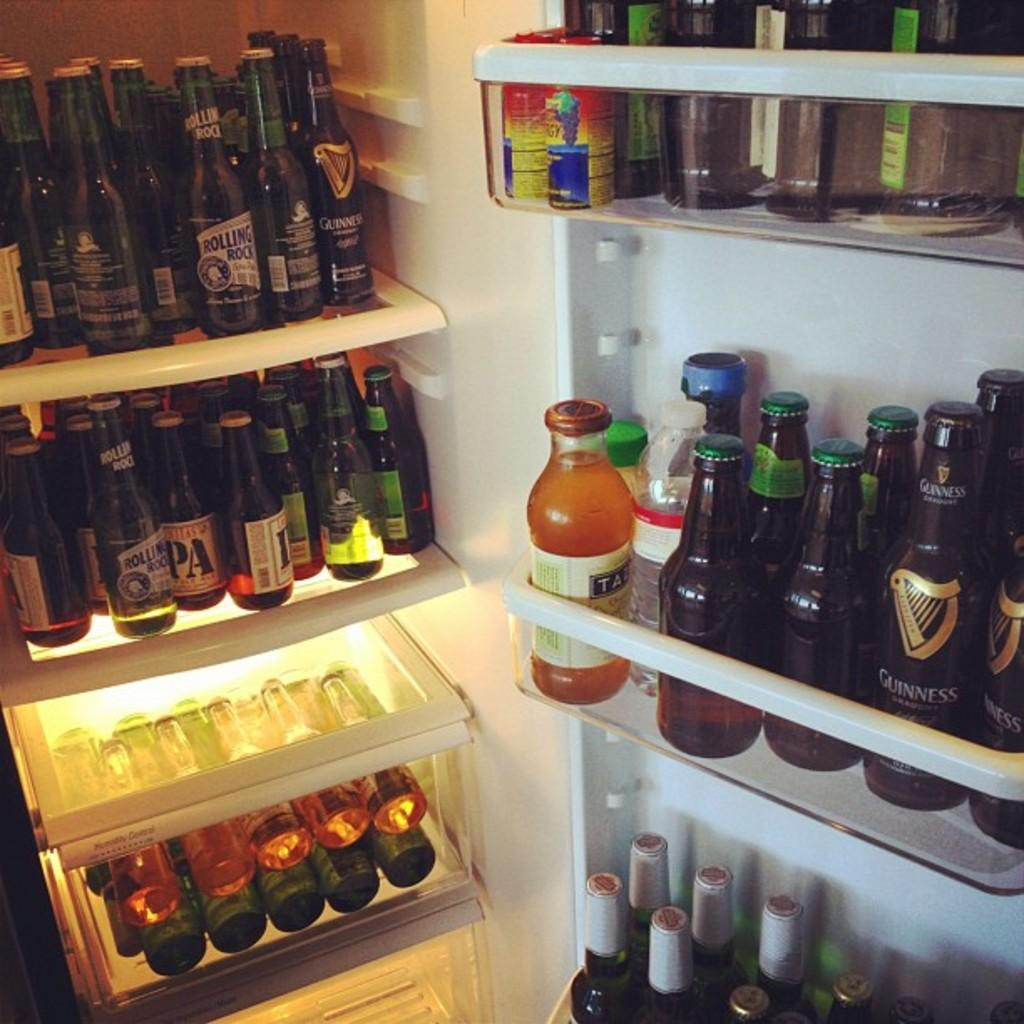What appliance can be seen in the image? There is a fridge in the image. What is stored inside the fridge? There are bottles placed on different shelves in the fridge. Can you see a volleyball being played in the image? No, there is no volleyball or any indication of a game being played in the image. What color is the orange in the image? There is no orange present in the image. 